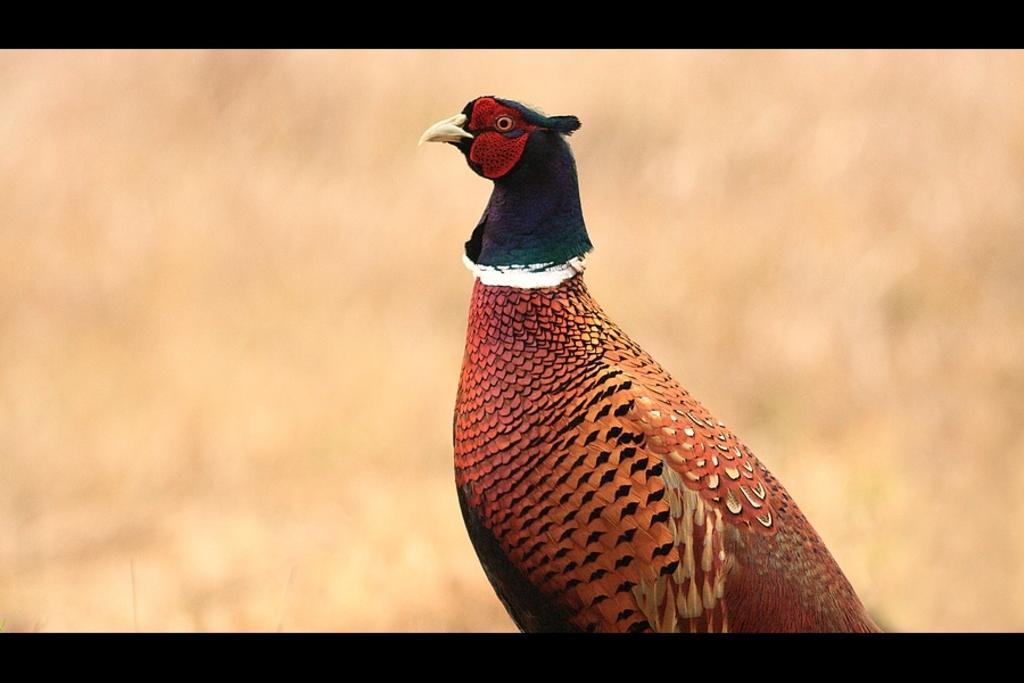What type of bird is in the image? There is a ring-necked pheasant in the image. Can you describe the background of the image? The background of the image is blurred. What color chalk is the carpenter using to draw on the wall in the image? There is no carpenter or chalk present in the image; it features a ring-necked pheasant with a blurred background. 